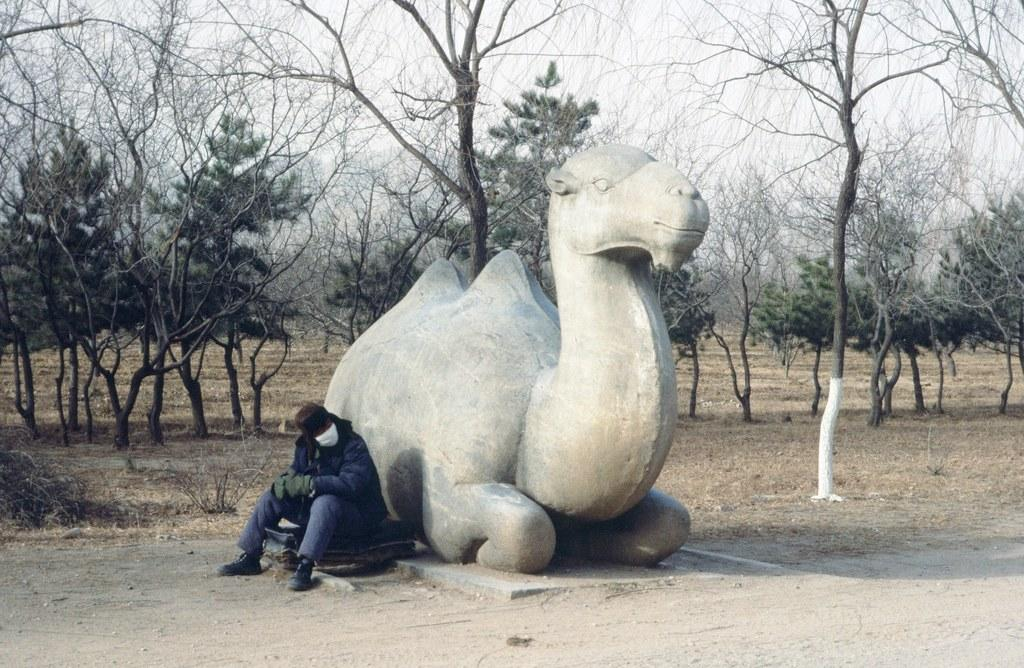What is the main subject of the image? There is a statue of a camel in the image. Can you describe the person in the image? There is a person sitting in the image. What can be seen in the background of the image? There are trees, grass, and the sky visible in the background of the image. What type of pest can be seen crawling on the statue in the image? There are no pests visible on the statue in the image. What is the person in the image using to lead the camel? There is no indication in the image that the person is leading the camel, nor is there any object present that could be used for leading. 